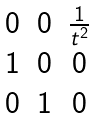<formula> <loc_0><loc_0><loc_500><loc_500>\begin{matrix} 0 & 0 & \frac { 1 } { t ^ { 2 } } \\ 1 & 0 & 0 \\ 0 & 1 & 0 \end{matrix}</formula> 